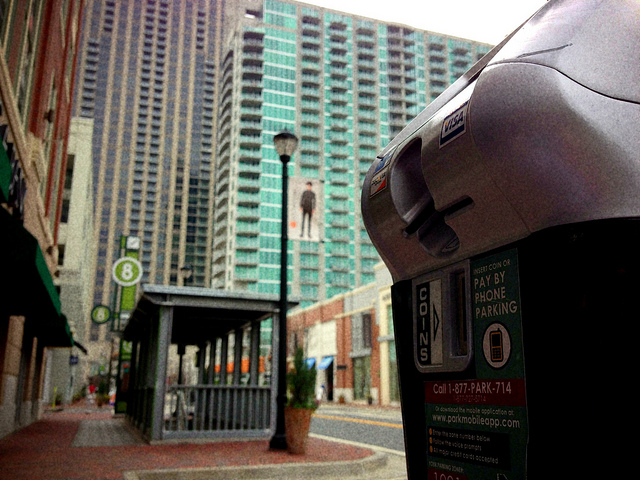Read all the text in this image. APY VISA PARKING BY 8 714 PARK 877 Call 8 